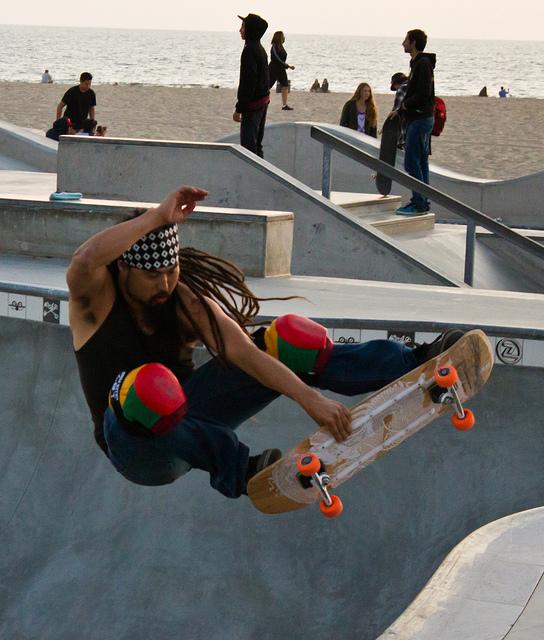Does this appear to be a California beach?
Concise answer only. Yes. Has this man been practicing this sport?
Be succinct. Yes. What is the man riding?
Keep it brief. Skateboard. 